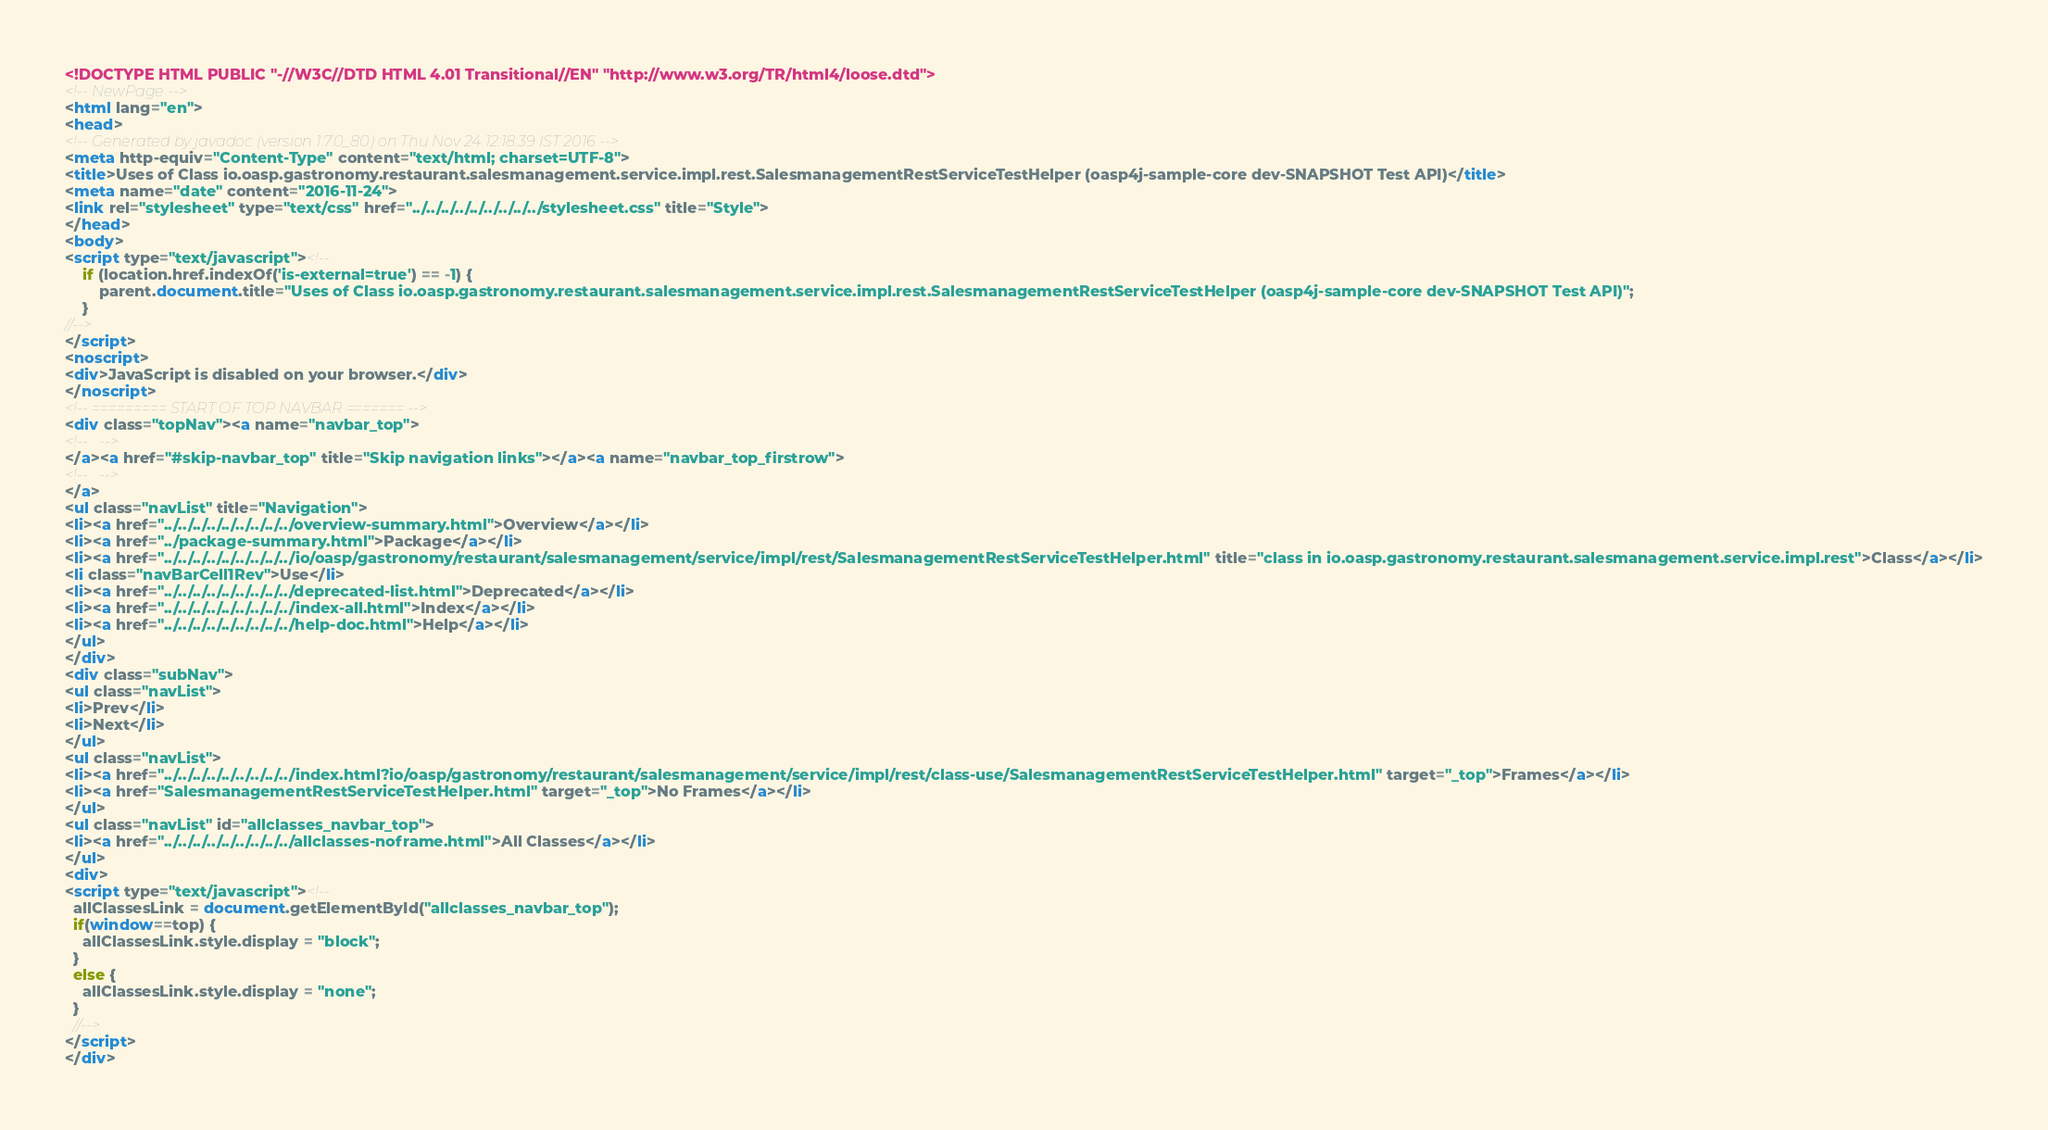<code> <loc_0><loc_0><loc_500><loc_500><_HTML_><!DOCTYPE HTML PUBLIC "-//W3C//DTD HTML 4.01 Transitional//EN" "http://www.w3.org/TR/html4/loose.dtd">
<!-- NewPage -->
<html lang="en">
<head>
<!-- Generated by javadoc (version 1.7.0_80) on Thu Nov 24 12:18:39 IST 2016 -->
<meta http-equiv="Content-Type" content="text/html; charset=UTF-8">
<title>Uses of Class io.oasp.gastronomy.restaurant.salesmanagement.service.impl.rest.SalesmanagementRestServiceTestHelper (oasp4j-sample-core dev-SNAPSHOT Test API)</title>
<meta name="date" content="2016-11-24">
<link rel="stylesheet" type="text/css" href="../../../../../../../../../stylesheet.css" title="Style">
</head>
<body>
<script type="text/javascript"><!--
    if (location.href.indexOf('is-external=true') == -1) {
        parent.document.title="Uses of Class io.oasp.gastronomy.restaurant.salesmanagement.service.impl.rest.SalesmanagementRestServiceTestHelper (oasp4j-sample-core dev-SNAPSHOT Test API)";
    }
//-->
</script>
<noscript>
<div>JavaScript is disabled on your browser.</div>
</noscript>
<!-- ========= START OF TOP NAVBAR ======= -->
<div class="topNav"><a name="navbar_top">
<!--   -->
</a><a href="#skip-navbar_top" title="Skip navigation links"></a><a name="navbar_top_firstrow">
<!--   -->
</a>
<ul class="navList" title="Navigation">
<li><a href="../../../../../../../../../overview-summary.html">Overview</a></li>
<li><a href="../package-summary.html">Package</a></li>
<li><a href="../../../../../../../../../io/oasp/gastronomy/restaurant/salesmanagement/service/impl/rest/SalesmanagementRestServiceTestHelper.html" title="class in io.oasp.gastronomy.restaurant.salesmanagement.service.impl.rest">Class</a></li>
<li class="navBarCell1Rev">Use</li>
<li><a href="../../../../../../../../../deprecated-list.html">Deprecated</a></li>
<li><a href="../../../../../../../../../index-all.html">Index</a></li>
<li><a href="../../../../../../../../../help-doc.html">Help</a></li>
</ul>
</div>
<div class="subNav">
<ul class="navList">
<li>Prev</li>
<li>Next</li>
</ul>
<ul class="navList">
<li><a href="../../../../../../../../../index.html?io/oasp/gastronomy/restaurant/salesmanagement/service/impl/rest/class-use/SalesmanagementRestServiceTestHelper.html" target="_top">Frames</a></li>
<li><a href="SalesmanagementRestServiceTestHelper.html" target="_top">No Frames</a></li>
</ul>
<ul class="navList" id="allclasses_navbar_top">
<li><a href="../../../../../../../../../allclasses-noframe.html">All Classes</a></li>
</ul>
<div>
<script type="text/javascript"><!--
  allClassesLink = document.getElementById("allclasses_navbar_top");
  if(window==top) {
    allClassesLink.style.display = "block";
  }
  else {
    allClassesLink.style.display = "none";
  }
  //-->
</script>
</div></code> 